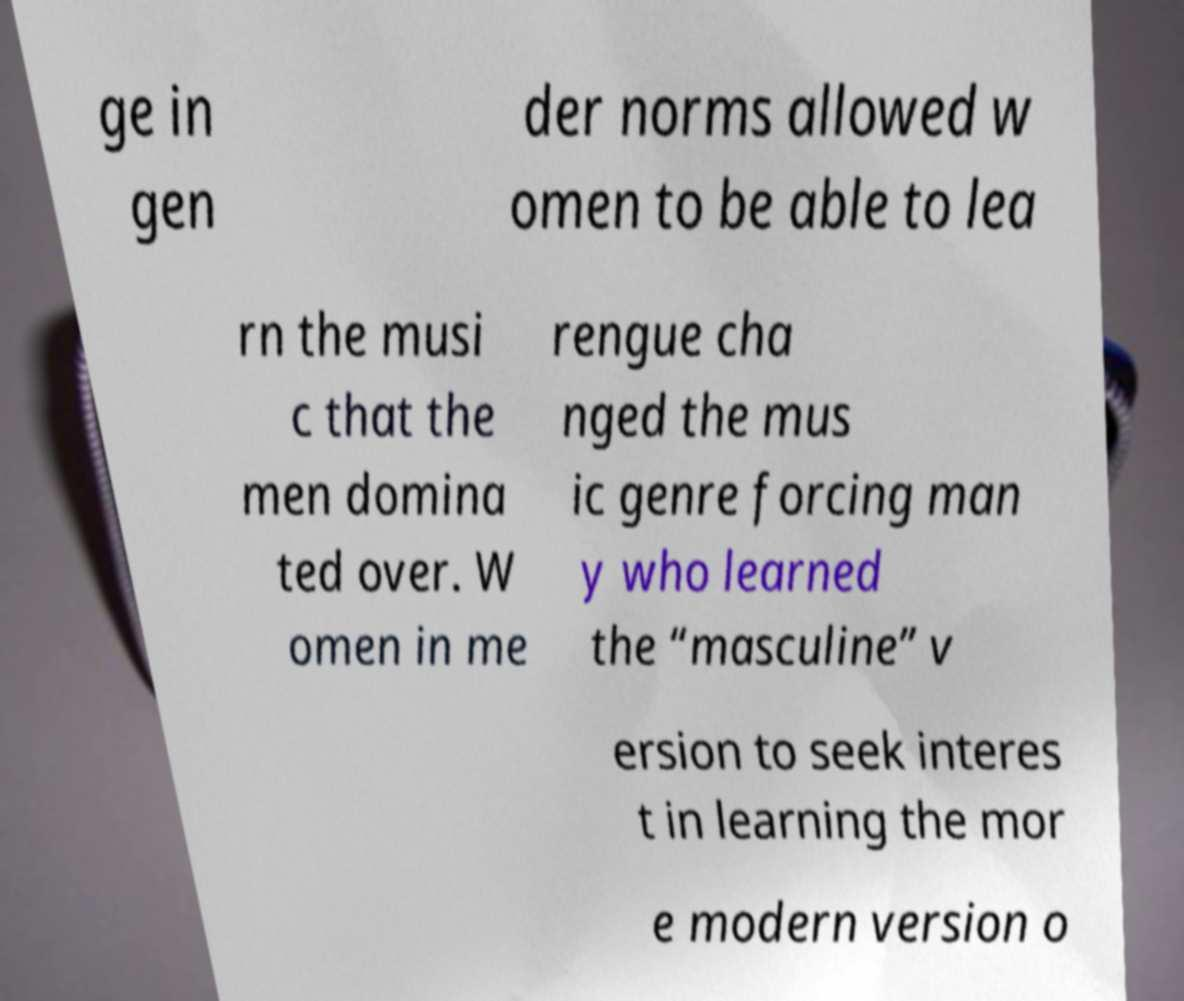There's text embedded in this image that I need extracted. Can you transcribe it verbatim? ge in gen der norms allowed w omen to be able to lea rn the musi c that the men domina ted over. W omen in me rengue cha nged the mus ic genre forcing man y who learned the “masculine” v ersion to seek interes t in learning the mor e modern version o 